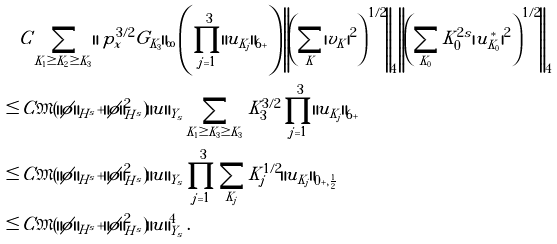<formula> <loc_0><loc_0><loc_500><loc_500>& C \sum _ { K _ { 1 } \geq K _ { 2 } \geq K _ { 3 } } \| \ p ^ { 3 / 2 } _ { x } G _ { K _ { 3 } } \| _ { \infty } \left ( \prod _ { j = 1 } ^ { 3 } \| u _ { K _ { j } } \| _ { 6 + } \right ) \left \| \left ( \sum _ { K } | v _ { K } | ^ { 2 } \right ) ^ { 1 / 2 } \right \| _ { 4 } \left \| \left ( \sum _ { K _ { 0 } } K _ { 0 } ^ { 2 s } | u _ { K _ { 0 } } ^ { * } | ^ { 2 } \right ) ^ { 1 / 2 } \right \| _ { 4 } \\ \leq & \, C \mathfrak { M } ( \| \phi \| _ { H ^ { s } } + \| \phi \| _ { H ^ { s } } ^ { 2 } ) \| u \| _ { Y _ { s } } \sum _ { K _ { 1 } \geq K _ { 3 } \geq K _ { 3 } } K _ { 3 } ^ { 3 / 2 } \prod _ { j = 1 } ^ { 3 } \| u _ { K _ { j } } \| _ { 6 + } \\ \leq & \, C \mathfrak { M } ( \| \phi \| _ { H ^ { s } } + \| \phi \| _ { H ^ { s } } ^ { 2 } ) \| u \| _ { Y _ { s } } \prod _ { j = 1 } ^ { 3 } \sum _ { K _ { j } } K _ { j } ^ { 1 / 2 } \| u _ { K _ { j } } \| _ { 0 + , \frac { 1 } { 2 } } \\ \leq & \, C \mathfrak { M } ( \| \phi \| _ { H ^ { s } } + \| \phi \| _ { H ^ { s } } ^ { 2 } ) \| u \| _ { Y _ { s } } ^ { 4 } \, .</formula> 